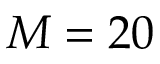Convert formula to latex. <formula><loc_0><loc_0><loc_500><loc_500>M = 2 0</formula> 